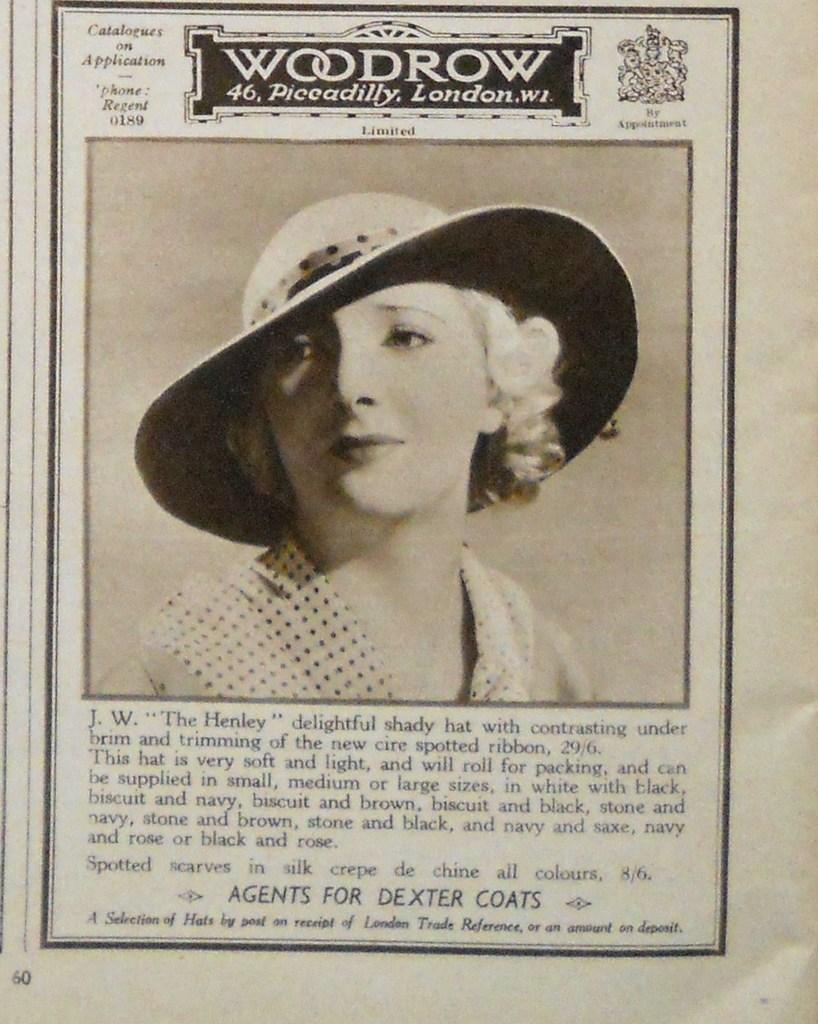What is the main object in the image? There is a newspaper in the image. What can be seen in the newspaper? The newspaper contains an image of a woman. What type of whip is the woman using in the image? There is no whip present in the image; it only contains an image of a woman. Is the woman swimming in the image? There is no indication of swimming in the image, as it only contains an image of a woman. 